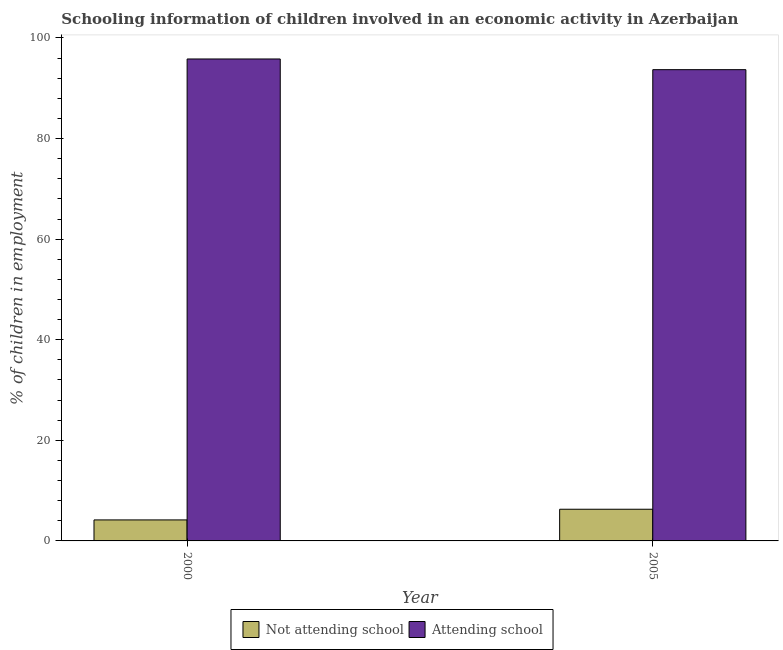How many bars are there on the 2nd tick from the left?
Provide a short and direct response. 2. What is the label of the 1st group of bars from the left?
Make the answer very short. 2000. In how many cases, is the number of bars for a given year not equal to the number of legend labels?
Make the answer very short. 0. Across all years, what is the maximum percentage of employed children who are attending school?
Offer a terse response. 95.82. Across all years, what is the minimum percentage of employed children who are not attending school?
Your answer should be very brief. 4.18. What is the total percentage of employed children who are not attending school in the graph?
Your answer should be very brief. 10.48. What is the difference between the percentage of employed children who are not attending school in 2000 and that in 2005?
Provide a short and direct response. -2.12. What is the difference between the percentage of employed children who are attending school in 2005 and the percentage of employed children who are not attending school in 2000?
Ensure brevity in your answer.  -2.12. What is the average percentage of employed children who are attending school per year?
Ensure brevity in your answer.  94.76. In how many years, is the percentage of employed children who are not attending school greater than 52 %?
Offer a very short reply. 0. What is the ratio of the percentage of employed children who are not attending school in 2000 to that in 2005?
Your answer should be very brief. 0.66. What does the 2nd bar from the left in 2000 represents?
Keep it short and to the point. Attending school. What does the 2nd bar from the right in 2005 represents?
Keep it short and to the point. Not attending school. How many bars are there?
Provide a short and direct response. 4. Are all the bars in the graph horizontal?
Your answer should be very brief. No. How many years are there in the graph?
Provide a succinct answer. 2. Does the graph contain grids?
Your response must be concise. No. What is the title of the graph?
Ensure brevity in your answer.  Schooling information of children involved in an economic activity in Azerbaijan. Does "Lower secondary education" appear as one of the legend labels in the graph?
Your answer should be compact. No. What is the label or title of the X-axis?
Your answer should be compact. Year. What is the label or title of the Y-axis?
Provide a succinct answer. % of children in employment. What is the % of children in employment of Not attending school in 2000?
Give a very brief answer. 4.18. What is the % of children in employment of Attending school in 2000?
Give a very brief answer. 95.82. What is the % of children in employment of Attending school in 2005?
Your response must be concise. 93.7. Across all years, what is the maximum % of children in employment in Not attending school?
Provide a succinct answer. 6.3. Across all years, what is the maximum % of children in employment of Attending school?
Give a very brief answer. 95.82. Across all years, what is the minimum % of children in employment of Not attending school?
Your answer should be compact. 4.18. Across all years, what is the minimum % of children in employment in Attending school?
Your response must be concise. 93.7. What is the total % of children in employment in Not attending school in the graph?
Keep it short and to the point. 10.48. What is the total % of children in employment in Attending school in the graph?
Ensure brevity in your answer.  189.52. What is the difference between the % of children in employment in Not attending school in 2000 and that in 2005?
Offer a very short reply. -2.12. What is the difference between the % of children in employment in Attending school in 2000 and that in 2005?
Keep it short and to the point. 2.12. What is the difference between the % of children in employment in Not attending school in 2000 and the % of children in employment in Attending school in 2005?
Provide a succinct answer. -89.52. What is the average % of children in employment in Not attending school per year?
Your answer should be very brief. 5.24. What is the average % of children in employment of Attending school per year?
Your answer should be very brief. 94.76. In the year 2000, what is the difference between the % of children in employment in Not attending school and % of children in employment in Attending school?
Provide a short and direct response. -91.65. In the year 2005, what is the difference between the % of children in employment in Not attending school and % of children in employment in Attending school?
Provide a succinct answer. -87.4. What is the ratio of the % of children in employment in Not attending school in 2000 to that in 2005?
Ensure brevity in your answer.  0.66. What is the ratio of the % of children in employment in Attending school in 2000 to that in 2005?
Ensure brevity in your answer.  1.02. What is the difference between the highest and the second highest % of children in employment in Not attending school?
Your response must be concise. 2.12. What is the difference between the highest and the second highest % of children in employment of Attending school?
Your answer should be very brief. 2.12. What is the difference between the highest and the lowest % of children in employment of Not attending school?
Offer a terse response. 2.12. What is the difference between the highest and the lowest % of children in employment in Attending school?
Make the answer very short. 2.12. 